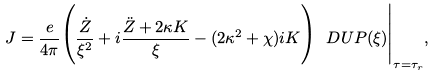<formula> <loc_0><loc_0><loc_500><loc_500>J = \frac { e } { 4 \pi } \Big ( \frac { \dot { Z } } { \xi ^ { 2 } } + i \frac { \ddot { Z } + 2 \kappa K } { \xi } - ( 2 \kappa ^ { 2 } + \chi ) i K \Big ) \ D U P ( \xi ) \Big | _ { \tau = \tau _ { r } } ,</formula> 